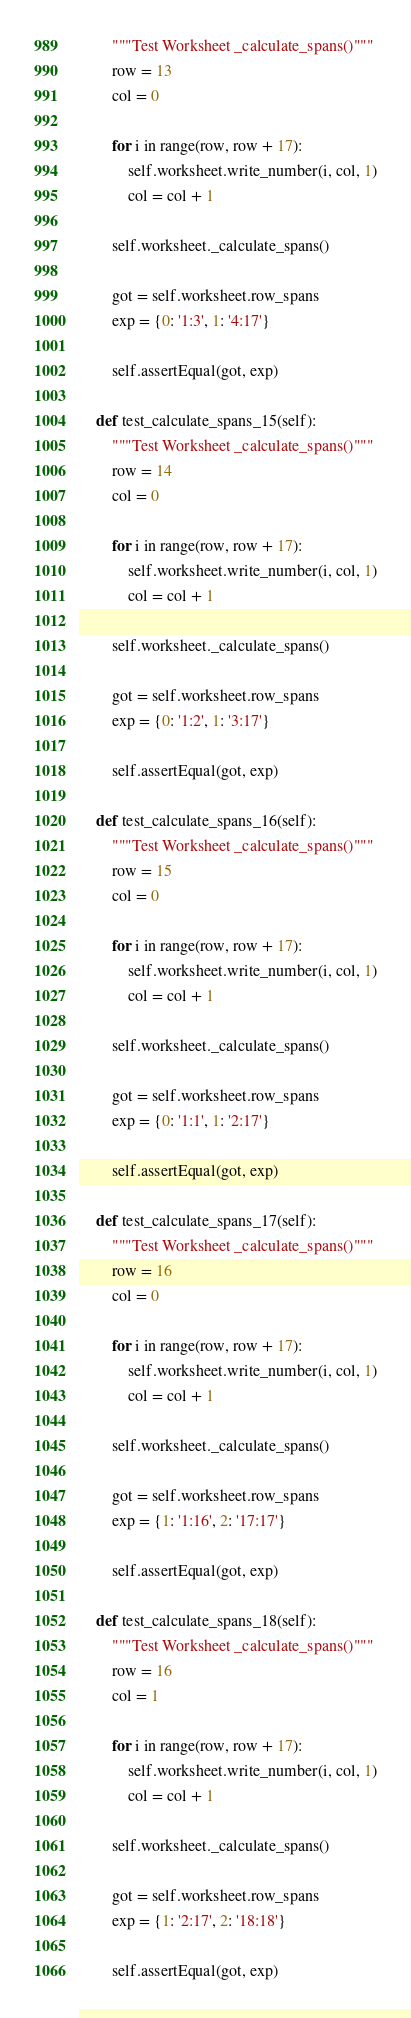<code> <loc_0><loc_0><loc_500><loc_500><_Python_>        """Test Worksheet _calculate_spans()"""
        row = 13
        col = 0

        for i in range(row, row + 17):
            self.worksheet.write_number(i, col, 1)
            col = col + 1

        self.worksheet._calculate_spans()

        got = self.worksheet.row_spans
        exp = {0: '1:3', 1: '4:17'}

        self.assertEqual(got, exp)

    def test_calculate_spans_15(self):
        """Test Worksheet _calculate_spans()"""
        row = 14
        col = 0

        for i in range(row, row + 17):
            self.worksheet.write_number(i, col, 1)
            col = col + 1

        self.worksheet._calculate_spans()

        got = self.worksheet.row_spans
        exp = {0: '1:2', 1: '3:17'}

        self.assertEqual(got, exp)

    def test_calculate_spans_16(self):
        """Test Worksheet _calculate_spans()"""
        row = 15
        col = 0

        for i in range(row, row + 17):
            self.worksheet.write_number(i, col, 1)
            col = col + 1

        self.worksheet._calculate_spans()

        got = self.worksheet.row_spans
        exp = {0: '1:1', 1: '2:17'}

        self.assertEqual(got, exp)

    def test_calculate_spans_17(self):
        """Test Worksheet _calculate_spans()"""
        row = 16
        col = 0

        for i in range(row, row + 17):
            self.worksheet.write_number(i, col, 1)
            col = col + 1

        self.worksheet._calculate_spans()

        got = self.worksheet.row_spans
        exp = {1: '1:16', 2: '17:17'}

        self.assertEqual(got, exp)

    def test_calculate_spans_18(self):
        """Test Worksheet _calculate_spans()"""
        row = 16
        col = 1

        for i in range(row, row + 17):
            self.worksheet.write_number(i, col, 1)
            col = col + 1

        self.worksheet._calculate_spans()

        got = self.worksheet.row_spans
        exp = {1: '2:17', 2: '18:18'}

        self.assertEqual(got, exp)
</code> 